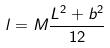Convert formula to latex. <formula><loc_0><loc_0><loc_500><loc_500>l = M \frac { L ^ { 2 } + b ^ { 2 } } { 1 2 }</formula> 